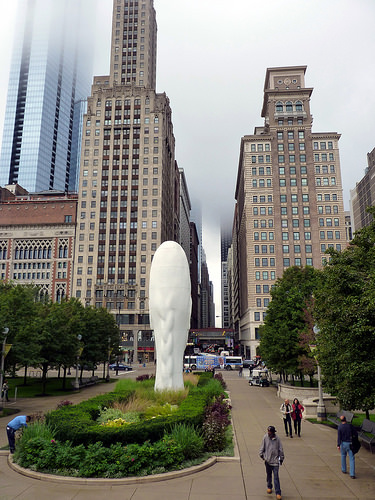<image>
Is there a person on the sidewalk? Yes. Looking at the image, I can see the person is positioned on top of the sidewalk, with the sidewalk providing support. Where is the water falls in relation to the building? Is it to the left of the building? No. The water falls is not to the left of the building. From this viewpoint, they have a different horizontal relationship. Where is the small building in relation to the big building? Is it to the left of the big building? No. The small building is not to the left of the big building. From this viewpoint, they have a different horizontal relationship. 